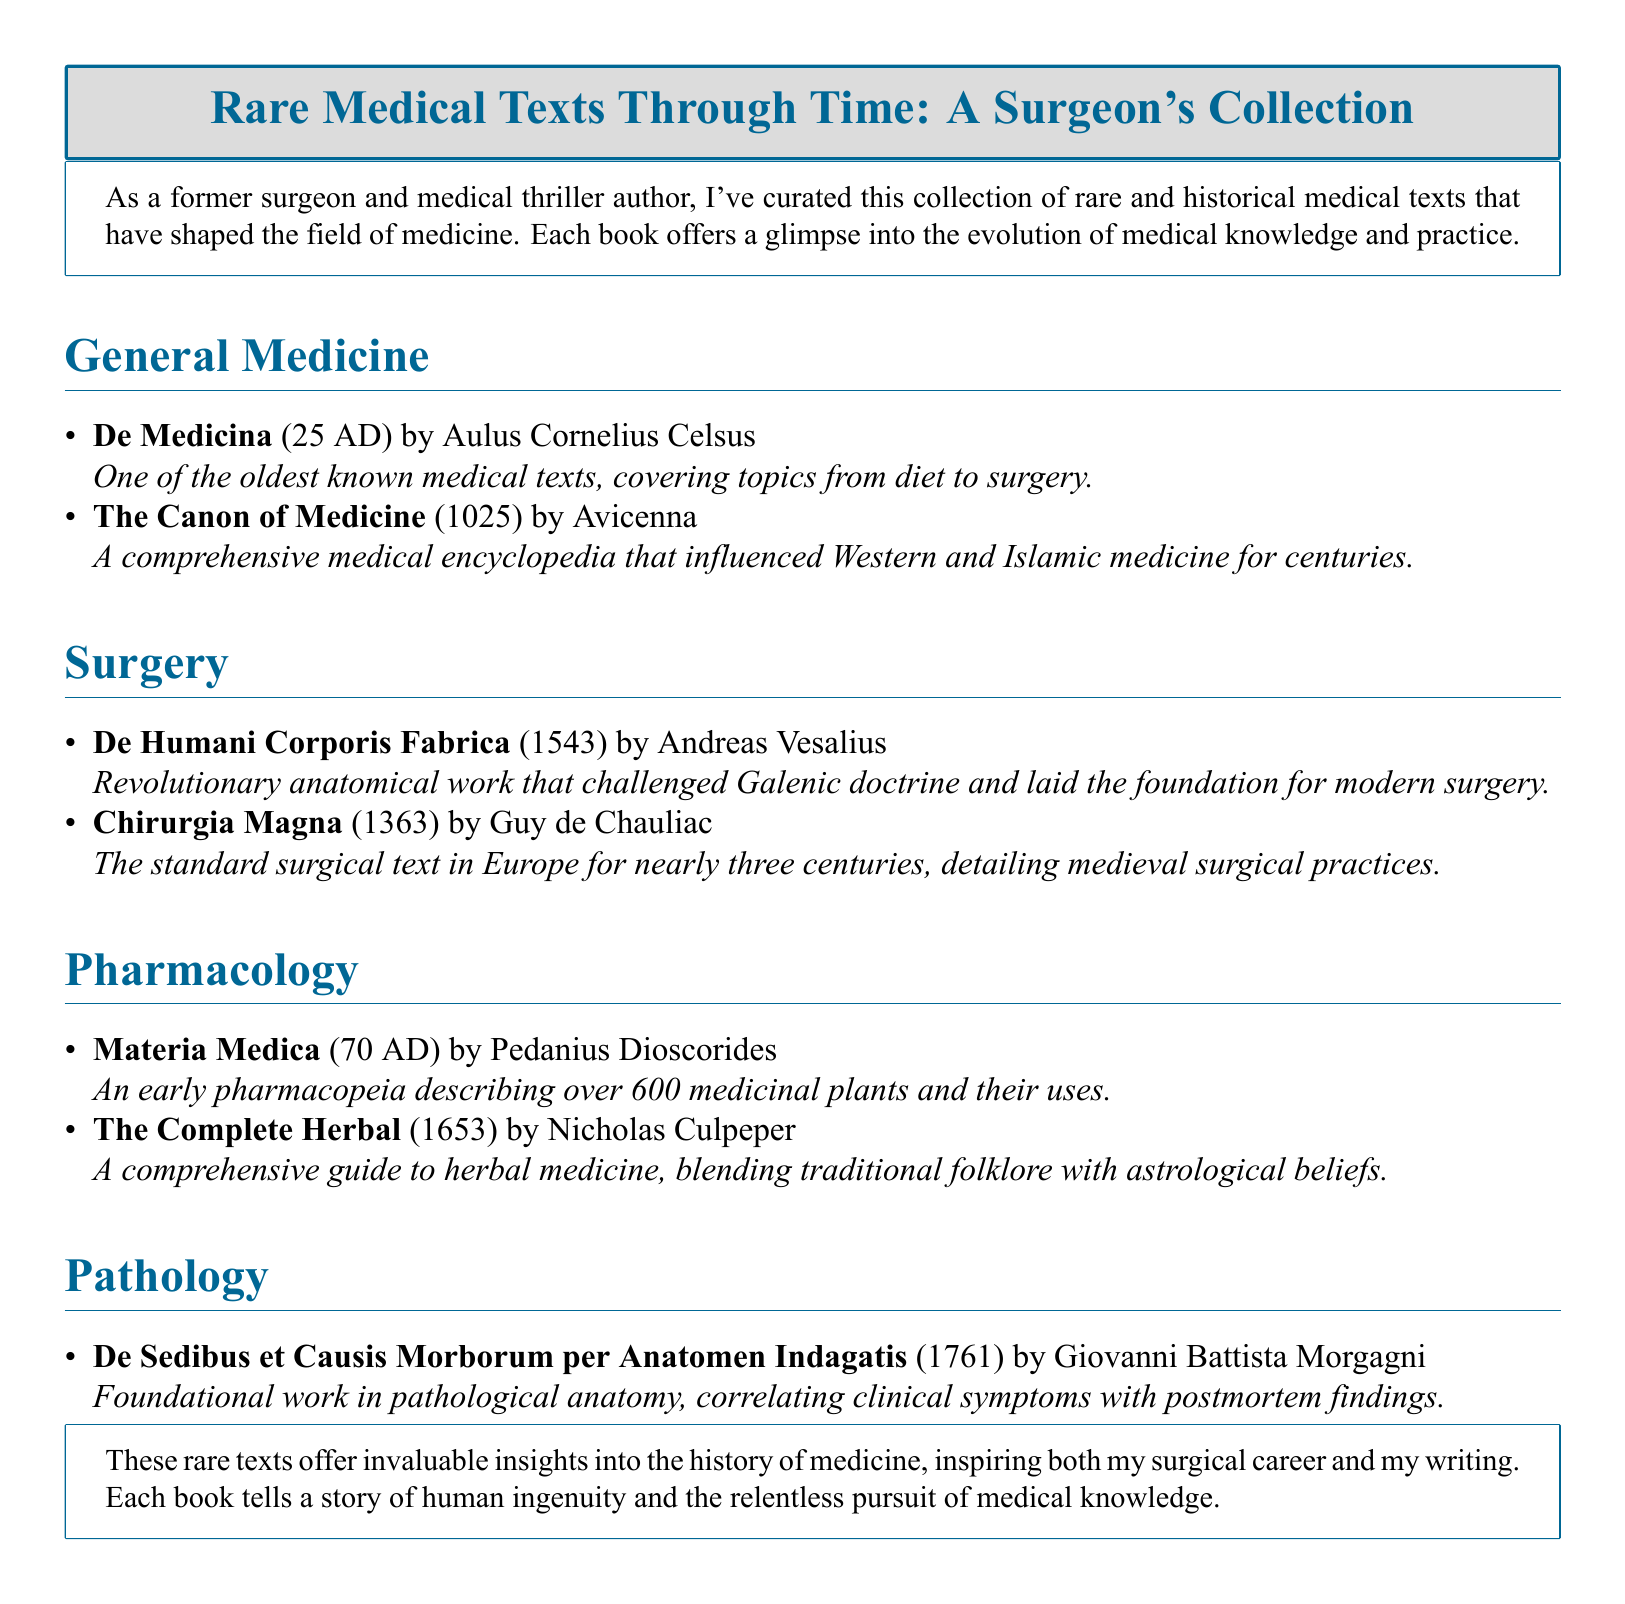What is the title of the first book listed in General Medicine? The first book listed in General Medicine is "De Medicina."
Answer: De Medicina Who authored "The Canon of Medicine"? The author of "The Canon of Medicine" is Avicenna.
Answer: Avicenna In what year was "De Humani Corporis Fabrica" published? "De Humani Corporis Fabrica" was published in 1543.
Answer: 1543 Which medical specialty has the book "Chirurgia Magna"? "Chirurgia Magna" belongs to the specialty of Surgery.
Answer: Surgery What type of work is "De Sedibus et Causis Morborum per Anatomen Indagatis"? It is a foundational work in pathological anatomy.
Answer: Foundational work in pathological anatomy Which book is described as an early pharmacopeia? The book described as an early pharmacopeia is "Materia Medica."
Answer: Materia Medica How many medicinal plants does "Materia Medica" describe? "Materia Medica" describes over 600 medicinal plants.
Answer: Over 600 What is the main focus of the book "The Complete Herbal"? The main focus of "The Complete Herbal" is herbal medicine.
Answer: Herbal medicine What significant contribution did "De Humani Corporis Fabrica" make to surgery? It challenged Galenic doctrine and laid the foundation for modern surgery.
Answer: Challenged Galenic doctrine and laid the foundation for modern surgery 